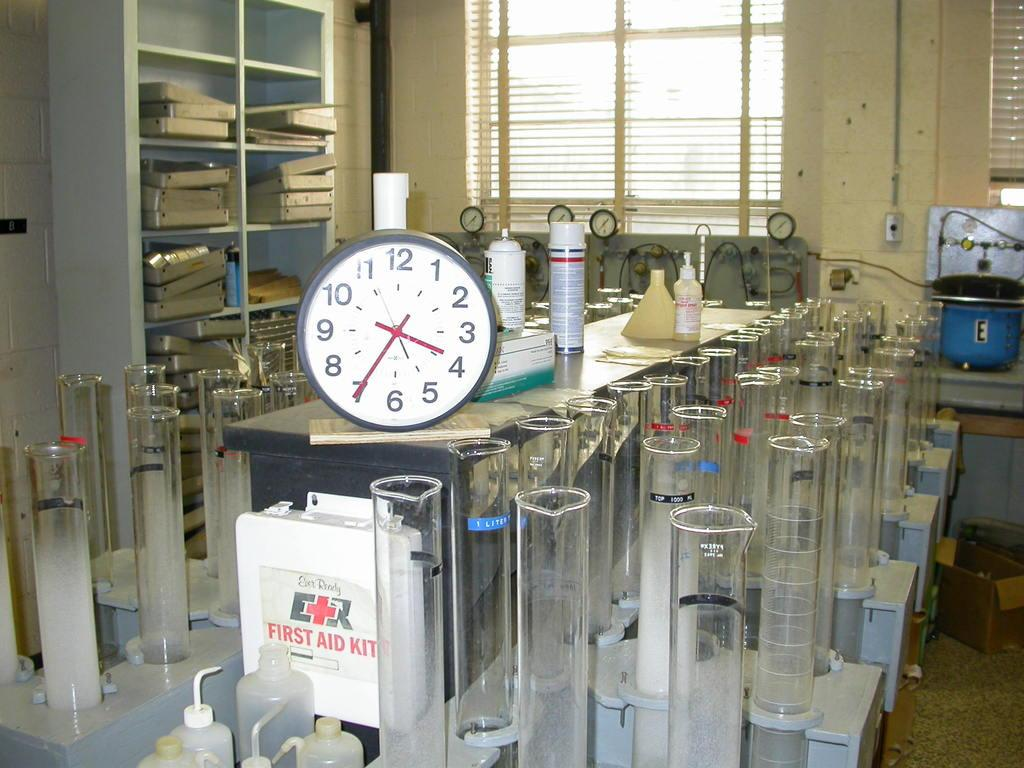<image>
Summarize the visual content of the image. The time on the clock in the chemistry lab is 3:35. 